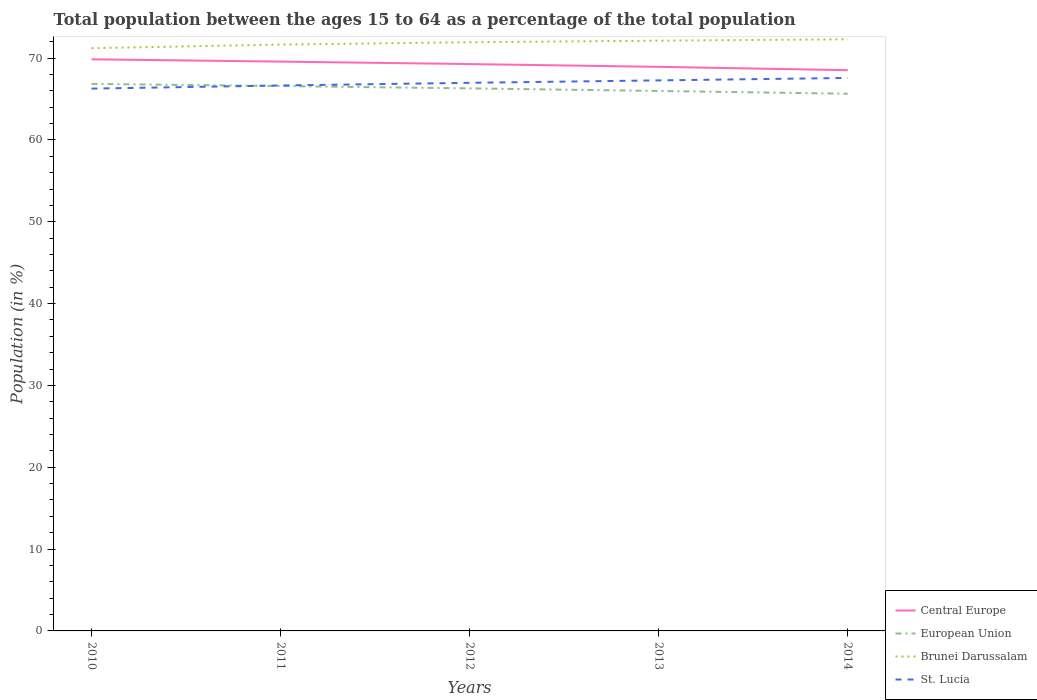Does the line corresponding to St. Lucia intersect with the line corresponding to Brunei Darussalam?
Offer a very short reply. No. Is the number of lines equal to the number of legend labels?
Provide a succinct answer. Yes. Across all years, what is the maximum percentage of the population ages 15 to 64 in Brunei Darussalam?
Make the answer very short. 71.21. In which year was the percentage of the population ages 15 to 64 in St. Lucia maximum?
Ensure brevity in your answer.  2010. What is the total percentage of the population ages 15 to 64 in European Union in the graph?
Keep it short and to the point. 1.2. What is the difference between the highest and the second highest percentage of the population ages 15 to 64 in St. Lucia?
Your answer should be very brief. 1.3. What is the difference between the highest and the lowest percentage of the population ages 15 to 64 in Brunei Darussalam?
Offer a very short reply. 3. How many years are there in the graph?
Provide a short and direct response. 5. Are the values on the major ticks of Y-axis written in scientific E-notation?
Make the answer very short. No. Does the graph contain grids?
Offer a very short reply. No. Where does the legend appear in the graph?
Provide a short and direct response. Bottom right. What is the title of the graph?
Provide a succinct answer. Total population between the ages 15 to 64 as a percentage of the total population. Does "Portugal" appear as one of the legend labels in the graph?
Ensure brevity in your answer.  No. What is the label or title of the Y-axis?
Your answer should be very brief. Population (in %). What is the Population (in %) in Central Europe in 2010?
Make the answer very short. 69.85. What is the Population (in %) of European Union in 2010?
Offer a terse response. 66.85. What is the Population (in %) of Brunei Darussalam in 2010?
Ensure brevity in your answer.  71.21. What is the Population (in %) in St. Lucia in 2010?
Offer a terse response. 66.27. What is the Population (in %) in Central Europe in 2011?
Ensure brevity in your answer.  69.57. What is the Population (in %) of European Union in 2011?
Provide a succinct answer. 66.58. What is the Population (in %) of Brunei Darussalam in 2011?
Offer a very short reply. 71.65. What is the Population (in %) of St. Lucia in 2011?
Offer a terse response. 66.65. What is the Population (in %) in Central Europe in 2012?
Your answer should be very brief. 69.27. What is the Population (in %) in European Union in 2012?
Provide a succinct answer. 66.3. What is the Population (in %) of Brunei Darussalam in 2012?
Offer a very short reply. 71.94. What is the Population (in %) of St. Lucia in 2012?
Provide a succinct answer. 66.98. What is the Population (in %) of Central Europe in 2013?
Ensure brevity in your answer.  68.93. What is the Population (in %) of European Union in 2013?
Offer a terse response. 65.99. What is the Population (in %) of Brunei Darussalam in 2013?
Make the answer very short. 72.13. What is the Population (in %) in St. Lucia in 2013?
Your response must be concise. 67.28. What is the Population (in %) of Central Europe in 2014?
Provide a short and direct response. 68.52. What is the Population (in %) of European Union in 2014?
Provide a short and direct response. 65.65. What is the Population (in %) of Brunei Darussalam in 2014?
Ensure brevity in your answer.  72.3. What is the Population (in %) in St. Lucia in 2014?
Provide a short and direct response. 67.58. Across all years, what is the maximum Population (in %) in Central Europe?
Keep it short and to the point. 69.85. Across all years, what is the maximum Population (in %) in European Union?
Make the answer very short. 66.85. Across all years, what is the maximum Population (in %) in Brunei Darussalam?
Your response must be concise. 72.3. Across all years, what is the maximum Population (in %) in St. Lucia?
Offer a very short reply. 67.58. Across all years, what is the minimum Population (in %) in Central Europe?
Your answer should be compact. 68.52. Across all years, what is the minimum Population (in %) of European Union?
Your response must be concise. 65.65. Across all years, what is the minimum Population (in %) of Brunei Darussalam?
Keep it short and to the point. 71.21. Across all years, what is the minimum Population (in %) in St. Lucia?
Give a very brief answer. 66.27. What is the total Population (in %) of Central Europe in the graph?
Give a very brief answer. 346.15. What is the total Population (in %) of European Union in the graph?
Keep it short and to the point. 331.36. What is the total Population (in %) in Brunei Darussalam in the graph?
Provide a succinct answer. 359.23. What is the total Population (in %) in St. Lucia in the graph?
Provide a succinct answer. 334.76. What is the difference between the Population (in %) of Central Europe in 2010 and that in 2011?
Your response must be concise. 0.28. What is the difference between the Population (in %) in European Union in 2010 and that in 2011?
Make the answer very short. 0.26. What is the difference between the Population (in %) of Brunei Darussalam in 2010 and that in 2011?
Make the answer very short. -0.44. What is the difference between the Population (in %) in St. Lucia in 2010 and that in 2011?
Offer a terse response. -0.38. What is the difference between the Population (in %) in Central Europe in 2010 and that in 2012?
Keep it short and to the point. 0.58. What is the difference between the Population (in %) of European Union in 2010 and that in 2012?
Provide a succinct answer. 0.55. What is the difference between the Population (in %) of Brunei Darussalam in 2010 and that in 2012?
Your answer should be compact. -0.73. What is the difference between the Population (in %) in St. Lucia in 2010 and that in 2012?
Keep it short and to the point. -0.71. What is the difference between the Population (in %) in Central Europe in 2010 and that in 2013?
Your answer should be very brief. 0.92. What is the difference between the Population (in %) in European Union in 2010 and that in 2013?
Make the answer very short. 0.86. What is the difference between the Population (in %) in Brunei Darussalam in 2010 and that in 2013?
Offer a very short reply. -0.92. What is the difference between the Population (in %) of St. Lucia in 2010 and that in 2013?
Your answer should be compact. -1. What is the difference between the Population (in %) in Central Europe in 2010 and that in 2014?
Your answer should be compact. 1.33. What is the difference between the Population (in %) of European Union in 2010 and that in 2014?
Keep it short and to the point. 1.2. What is the difference between the Population (in %) in Brunei Darussalam in 2010 and that in 2014?
Your answer should be compact. -1.09. What is the difference between the Population (in %) in St. Lucia in 2010 and that in 2014?
Offer a terse response. -1.3. What is the difference between the Population (in %) in Central Europe in 2011 and that in 2012?
Your answer should be compact. 0.3. What is the difference between the Population (in %) of European Union in 2011 and that in 2012?
Your answer should be compact. 0.28. What is the difference between the Population (in %) of Brunei Darussalam in 2011 and that in 2012?
Your response must be concise. -0.29. What is the difference between the Population (in %) in St. Lucia in 2011 and that in 2012?
Give a very brief answer. -0.32. What is the difference between the Population (in %) in Central Europe in 2011 and that in 2013?
Make the answer very short. 0.64. What is the difference between the Population (in %) in European Union in 2011 and that in 2013?
Provide a succinct answer. 0.6. What is the difference between the Population (in %) in Brunei Darussalam in 2011 and that in 2013?
Your answer should be very brief. -0.48. What is the difference between the Population (in %) of St. Lucia in 2011 and that in 2013?
Your response must be concise. -0.62. What is the difference between the Population (in %) in Central Europe in 2011 and that in 2014?
Provide a short and direct response. 1.05. What is the difference between the Population (in %) of European Union in 2011 and that in 2014?
Give a very brief answer. 0.94. What is the difference between the Population (in %) in Brunei Darussalam in 2011 and that in 2014?
Offer a terse response. -0.65. What is the difference between the Population (in %) of St. Lucia in 2011 and that in 2014?
Give a very brief answer. -0.92. What is the difference between the Population (in %) in Central Europe in 2012 and that in 2013?
Your response must be concise. 0.34. What is the difference between the Population (in %) in European Union in 2012 and that in 2013?
Make the answer very short. 0.31. What is the difference between the Population (in %) in Brunei Darussalam in 2012 and that in 2013?
Provide a succinct answer. -0.19. What is the difference between the Population (in %) in St. Lucia in 2012 and that in 2013?
Ensure brevity in your answer.  -0.3. What is the difference between the Population (in %) in Central Europe in 2012 and that in 2014?
Provide a short and direct response. 0.75. What is the difference between the Population (in %) of European Union in 2012 and that in 2014?
Provide a succinct answer. 0.65. What is the difference between the Population (in %) in Brunei Darussalam in 2012 and that in 2014?
Your response must be concise. -0.36. What is the difference between the Population (in %) of St. Lucia in 2012 and that in 2014?
Give a very brief answer. -0.6. What is the difference between the Population (in %) of Central Europe in 2013 and that in 2014?
Your answer should be compact. 0.41. What is the difference between the Population (in %) in European Union in 2013 and that in 2014?
Offer a very short reply. 0.34. What is the difference between the Population (in %) in Brunei Darussalam in 2013 and that in 2014?
Your answer should be compact. -0.17. What is the difference between the Population (in %) in St. Lucia in 2013 and that in 2014?
Your answer should be compact. -0.3. What is the difference between the Population (in %) of Central Europe in 2010 and the Population (in %) of European Union in 2011?
Your answer should be very brief. 3.27. What is the difference between the Population (in %) of Central Europe in 2010 and the Population (in %) of Brunei Darussalam in 2011?
Make the answer very short. -1.8. What is the difference between the Population (in %) in Central Europe in 2010 and the Population (in %) in St. Lucia in 2011?
Offer a terse response. 3.2. What is the difference between the Population (in %) of European Union in 2010 and the Population (in %) of Brunei Darussalam in 2011?
Offer a very short reply. -4.8. What is the difference between the Population (in %) in European Union in 2010 and the Population (in %) in St. Lucia in 2011?
Offer a terse response. 0.19. What is the difference between the Population (in %) in Brunei Darussalam in 2010 and the Population (in %) in St. Lucia in 2011?
Offer a very short reply. 4.56. What is the difference between the Population (in %) of Central Europe in 2010 and the Population (in %) of European Union in 2012?
Give a very brief answer. 3.55. What is the difference between the Population (in %) of Central Europe in 2010 and the Population (in %) of Brunei Darussalam in 2012?
Offer a very short reply. -2.09. What is the difference between the Population (in %) in Central Europe in 2010 and the Population (in %) in St. Lucia in 2012?
Offer a very short reply. 2.87. What is the difference between the Population (in %) in European Union in 2010 and the Population (in %) in Brunei Darussalam in 2012?
Offer a very short reply. -5.09. What is the difference between the Population (in %) in European Union in 2010 and the Population (in %) in St. Lucia in 2012?
Give a very brief answer. -0.13. What is the difference between the Population (in %) of Brunei Darussalam in 2010 and the Population (in %) of St. Lucia in 2012?
Ensure brevity in your answer.  4.23. What is the difference between the Population (in %) in Central Europe in 2010 and the Population (in %) in European Union in 2013?
Offer a terse response. 3.87. What is the difference between the Population (in %) of Central Europe in 2010 and the Population (in %) of Brunei Darussalam in 2013?
Provide a succinct answer. -2.28. What is the difference between the Population (in %) of Central Europe in 2010 and the Population (in %) of St. Lucia in 2013?
Keep it short and to the point. 2.58. What is the difference between the Population (in %) of European Union in 2010 and the Population (in %) of Brunei Darussalam in 2013?
Give a very brief answer. -5.28. What is the difference between the Population (in %) in European Union in 2010 and the Population (in %) in St. Lucia in 2013?
Offer a terse response. -0.43. What is the difference between the Population (in %) in Brunei Darussalam in 2010 and the Population (in %) in St. Lucia in 2013?
Provide a succinct answer. 3.93. What is the difference between the Population (in %) of Central Europe in 2010 and the Population (in %) of European Union in 2014?
Your response must be concise. 4.2. What is the difference between the Population (in %) in Central Europe in 2010 and the Population (in %) in Brunei Darussalam in 2014?
Your answer should be very brief. -2.45. What is the difference between the Population (in %) of Central Europe in 2010 and the Population (in %) of St. Lucia in 2014?
Your answer should be very brief. 2.28. What is the difference between the Population (in %) of European Union in 2010 and the Population (in %) of Brunei Darussalam in 2014?
Provide a succinct answer. -5.45. What is the difference between the Population (in %) of European Union in 2010 and the Population (in %) of St. Lucia in 2014?
Make the answer very short. -0.73. What is the difference between the Population (in %) of Brunei Darussalam in 2010 and the Population (in %) of St. Lucia in 2014?
Ensure brevity in your answer.  3.63. What is the difference between the Population (in %) in Central Europe in 2011 and the Population (in %) in European Union in 2012?
Your answer should be compact. 3.27. What is the difference between the Population (in %) of Central Europe in 2011 and the Population (in %) of Brunei Darussalam in 2012?
Your answer should be compact. -2.37. What is the difference between the Population (in %) in Central Europe in 2011 and the Population (in %) in St. Lucia in 2012?
Offer a very short reply. 2.59. What is the difference between the Population (in %) of European Union in 2011 and the Population (in %) of Brunei Darussalam in 2012?
Your response must be concise. -5.36. What is the difference between the Population (in %) in European Union in 2011 and the Population (in %) in St. Lucia in 2012?
Offer a very short reply. -0.39. What is the difference between the Population (in %) of Brunei Darussalam in 2011 and the Population (in %) of St. Lucia in 2012?
Offer a terse response. 4.67. What is the difference between the Population (in %) in Central Europe in 2011 and the Population (in %) in European Union in 2013?
Ensure brevity in your answer.  3.59. What is the difference between the Population (in %) of Central Europe in 2011 and the Population (in %) of Brunei Darussalam in 2013?
Provide a succinct answer. -2.56. What is the difference between the Population (in %) of Central Europe in 2011 and the Population (in %) of St. Lucia in 2013?
Your answer should be very brief. 2.3. What is the difference between the Population (in %) in European Union in 2011 and the Population (in %) in Brunei Darussalam in 2013?
Offer a terse response. -5.55. What is the difference between the Population (in %) in European Union in 2011 and the Population (in %) in St. Lucia in 2013?
Provide a short and direct response. -0.69. What is the difference between the Population (in %) in Brunei Darussalam in 2011 and the Population (in %) in St. Lucia in 2013?
Offer a terse response. 4.38. What is the difference between the Population (in %) of Central Europe in 2011 and the Population (in %) of European Union in 2014?
Your answer should be compact. 3.92. What is the difference between the Population (in %) in Central Europe in 2011 and the Population (in %) in Brunei Darussalam in 2014?
Provide a succinct answer. -2.73. What is the difference between the Population (in %) of Central Europe in 2011 and the Population (in %) of St. Lucia in 2014?
Make the answer very short. 2. What is the difference between the Population (in %) of European Union in 2011 and the Population (in %) of Brunei Darussalam in 2014?
Your answer should be very brief. -5.71. What is the difference between the Population (in %) of European Union in 2011 and the Population (in %) of St. Lucia in 2014?
Keep it short and to the point. -0.99. What is the difference between the Population (in %) of Brunei Darussalam in 2011 and the Population (in %) of St. Lucia in 2014?
Ensure brevity in your answer.  4.08. What is the difference between the Population (in %) in Central Europe in 2012 and the Population (in %) in European Union in 2013?
Provide a succinct answer. 3.29. What is the difference between the Population (in %) in Central Europe in 2012 and the Population (in %) in Brunei Darussalam in 2013?
Provide a short and direct response. -2.86. What is the difference between the Population (in %) in Central Europe in 2012 and the Population (in %) in St. Lucia in 2013?
Offer a very short reply. 1.99. What is the difference between the Population (in %) of European Union in 2012 and the Population (in %) of Brunei Darussalam in 2013?
Give a very brief answer. -5.83. What is the difference between the Population (in %) of European Union in 2012 and the Population (in %) of St. Lucia in 2013?
Ensure brevity in your answer.  -0.98. What is the difference between the Population (in %) in Brunei Darussalam in 2012 and the Population (in %) in St. Lucia in 2013?
Keep it short and to the point. 4.66. What is the difference between the Population (in %) of Central Europe in 2012 and the Population (in %) of European Union in 2014?
Your answer should be compact. 3.62. What is the difference between the Population (in %) in Central Europe in 2012 and the Population (in %) in Brunei Darussalam in 2014?
Keep it short and to the point. -3.03. What is the difference between the Population (in %) in Central Europe in 2012 and the Population (in %) in St. Lucia in 2014?
Offer a very short reply. 1.69. What is the difference between the Population (in %) in European Union in 2012 and the Population (in %) in Brunei Darussalam in 2014?
Provide a short and direct response. -6. What is the difference between the Population (in %) of European Union in 2012 and the Population (in %) of St. Lucia in 2014?
Your response must be concise. -1.28. What is the difference between the Population (in %) of Brunei Darussalam in 2012 and the Population (in %) of St. Lucia in 2014?
Offer a terse response. 4.36. What is the difference between the Population (in %) in Central Europe in 2013 and the Population (in %) in European Union in 2014?
Your answer should be compact. 3.28. What is the difference between the Population (in %) of Central Europe in 2013 and the Population (in %) of Brunei Darussalam in 2014?
Offer a terse response. -3.37. What is the difference between the Population (in %) of Central Europe in 2013 and the Population (in %) of St. Lucia in 2014?
Offer a terse response. 1.36. What is the difference between the Population (in %) of European Union in 2013 and the Population (in %) of Brunei Darussalam in 2014?
Ensure brevity in your answer.  -6.31. What is the difference between the Population (in %) in European Union in 2013 and the Population (in %) in St. Lucia in 2014?
Your answer should be compact. -1.59. What is the difference between the Population (in %) in Brunei Darussalam in 2013 and the Population (in %) in St. Lucia in 2014?
Make the answer very short. 4.55. What is the average Population (in %) in Central Europe per year?
Your response must be concise. 69.23. What is the average Population (in %) of European Union per year?
Offer a terse response. 66.27. What is the average Population (in %) in Brunei Darussalam per year?
Your answer should be very brief. 71.85. What is the average Population (in %) of St. Lucia per year?
Provide a succinct answer. 66.95. In the year 2010, what is the difference between the Population (in %) of Central Europe and Population (in %) of European Union?
Offer a very short reply. 3. In the year 2010, what is the difference between the Population (in %) of Central Europe and Population (in %) of Brunei Darussalam?
Your response must be concise. -1.36. In the year 2010, what is the difference between the Population (in %) in Central Europe and Population (in %) in St. Lucia?
Offer a very short reply. 3.58. In the year 2010, what is the difference between the Population (in %) in European Union and Population (in %) in Brunei Darussalam?
Offer a terse response. -4.36. In the year 2010, what is the difference between the Population (in %) in European Union and Population (in %) in St. Lucia?
Keep it short and to the point. 0.58. In the year 2010, what is the difference between the Population (in %) in Brunei Darussalam and Population (in %) in St. Lucia?
Offer a very short reply. 4.94. In the year 2011, what is the difference between the Population (in %) in Central Europe and Population (in %) in European Union?
Offer a very short reply. 2.99. In the year 2011, what is the difference between the Population (in %) in Central Europe and Population (in %) in Brunei Darussalam?
Your response must be concise. -2.08. In the year 2011, what is the difference between the Population (in %) of Central Europe and Population (in %) of St. Lucia?
Your answer should be compact. 2.92. In the year 2011, what is the difference between the Population (in %) in European Union and Population (in %) in Brunei Darussalam?
Make the answer very short. -5.07. In the year 2011, what is the difference between the Population (in %) in European Union and Population (in %) in St. Lucia?
Make the answer very short. -0.07. In the year 2011, what is the difference between the Population (in %) of Brunei Darussalam and Population (in %) of St. Lucia?
Ensure brevity in your answer.  5. In the year 2012, what is the difference between the Population (in %) in Central Europe and Population (in %) in European Union?
Make the answer very short. 2.97. In the year 2012, what is the difference between the Population (in %) of Central Europe and Population (in %) of Brunei Darussalam?
Keep it short and to the point. -2.67. In the year 2012, what is the difference between the Population (in %) of Central Europe and Population (in %) of St. Lucia?
Keep it short and to the point. 2.29. In the year 2012, what is the difference between the Population (in %) of European Union and Population (in %) of Brunei Darussalam?
Your answer should be very brief. -5.64. In the year 2012, what is the difference between the Population (in %) of European Union and Population (in %) of St. Lucia?
Offer a very short reply. -0.68. In the year 2012, what is the difference between the Population (in %) in Brunei Darussalam and Population (in %) in St. Lucia?
Keep it short and to the point. 4.96. In the year 2013, what is the difference between the Population (in %) of Central Europe and Population (in %) of European Union?
Provide a short and direct response. 2.95. In the year 2013, what is the difference between the Population (in %) in Central Europe and Population (in %) in Brunei Darussalam?
Your answer should be compact. -3.2. In the year 2013, what is the difference between the Population (in %) in Central Europe and Population (in %) in St. Lucia?
Your answer should be very brief. 1.66. In the year 2013, what is the difference between the Population (in %) in European Union and Population (in %) in Brunei Darussalam?
Provide a succinct answer. -6.14. In the year 2013, what is the difference between the Population (in %) of European Union and Population (in %) of St. Lucia?
Ensure brevity in your answer.  -1.29. In the year 2013, what is the difference between the Population (in %) in Brunei Darussalam and Population (in %) in St. Lucia?
Your response must be concise. 4.85. In the year 2014, what is the difference between the Population (in %) of Central Europe and Population (in %) of European Union?
Keep it short and to the point. 2.88. In the year 2014, what is the difference between the Population (in %) in Central Europe and Population (in %) in Brunei Darussalam?
Offer a very short reply. -3.77. In the year 2014, what is the difference between the Population (in %) of Central Europe and Population (in %) of St. Lucia?
Offer a very short reply. 0.95. In the year 2014, what is the difference between the Population (in %) in European Union and Population (in %) in Brunei Darussalam?
Provide a succinct answer. -6.65. In the year 2014, what is the difference between the Population (in %) of European Union and Population (in %) of St. Lucia?
Offer a very short reply. -1.93. In the year 2014, what is the difference between the Population (in %) in Brunei Darussalam and Population (in %) in St. Lucia?
Give a very brief answer. 4.72. What is the ratio of the Population (in %) in Central Europe in 2010 to that in 2011?
Offer a very short reply. 1. What is the ratio of the Population (in %) of European Union in 2010 to that in 2011?
Your answer should be compact. 1. What is the ratio of the Population (in %) in Brunei Darussalam in 2010 to that in 2011?
Your answer should be compact. 0.99. What is the ratio of the Population (in %) of Central Europe in 2010 to that in 2012?
Make the answer very short. 1.01. What is the ratio of the Population (in %) in European Union in 2010 to that in 2012?
Keep it short and to the point. 1.01. What is the ratio of the Population (in %) of Central Europe in 2010 to that in 2013?
Make the answer very short. 1.01. What is the ratio of the Population (in %) in European Union in 2010 to that in 2013?
Offer a terse response. 1.01. What is the ratio of the Population (in %) of Brunei Darussalam in 2010 to that in 2013?
Your answer should be very brief. 0.99. What is the ratio of the Population (in %) in St. Lucia in 2010 to that in 2013?
Make the answer very short. 0.99. What is the ratio of the Population (in %) in Central Europe in 2010 to that in 2014?
Make the answer very short. 1.02. What is the ratio of the Population (in %) of European Union in 2010 to that in 2014?
Your answer should be compact. 1.02. What is the ratio of the Population (in %) in St. Lucia in 2010 to that in 2014?
Provide a short and direct response. 0.98. What is the ratio of the Population (in %) in European Union in 2011 to that in 2012?
Provide a succinct answer. 1. What is the ratio of the Population (in %) in Central Europe in 2011 to that in 2013?
Make the answer very short. 1.01. What is the ratio of the Population (in %) in European Union in 2011 to that in 2013?
Make the answer very short. 1.01. What is the ratio of the Population (in %) in Brunei Darussalam in 2011 to that in 2013?
Offer a terse response. 0.99. What is the ratio of the Population (in %) of St. Lucia in 2011 to that in 2013?
Offer a very short reply. 0.99. What is the ratio of the Population (in %) in Central Europe in 2011 to that in 2014?
Offer a terse response. 1.02. What is the ratio of the Population (in %) of European Union in 2011 to that in 2014?
Ensure brevity in your answer.  1.01. What is the ratio of the Population (in %) of Brunei Darussalam in 2011 to that in 2014?
Make the answer very short. 0.99. What is the ratio of the Population (in %) of St. Lucia in 2011 to that in 2014?
Offer a very short reply. 0.99. What is the ratio of the Population (in %) in Central Europe in 2012 to that in 2013?
Provide a short and direct response. 1. What is the ratio of the Population (in %) in St. Lucia in 2012 to that in 2013?
Your response must be concise. 1. What is the ratio of the Population (in %) in Central Europe in 2012 to that in 2014?
Offer a terse response. 1.01. What is the ratio of the Population (in %) of St. Lucia in 2012 to that in 2014?
Give a very brief answer. 0.99. What is the ratio of the Population (in %) of Central Europe in 2013 to that in 2014?
Offer a very short reply. 1.01. What is the ratio of the Population (in %) in European Union in 2013 to that in 2014?
Your answer should be compact. 1.01. What is the ratio of the Population (in %) in Brunei Darussalam in 2013 to that in 2014?
Offer a very short reply. 1. What is the ratio of the Population (in %) in St. Lucia in 2013 to that in 2014?
Offer a terse response. 1. What is the difference between the highest and the second highest Population (in %) of Central Europe?
Your answer should be compact. 0.28. What is the difference between the highest and the second highest Population (in %) in European Union?
Your response must be concise. 0.26. What is the difference between the highest and the second highest Population (in %) of Brunei Darussalam?
Ensure brevity in your answer.  0.17. What is the difference between the highest and the second highest Population (in %) in St. Lucia?
Provide a succinct answer. 0.3. What is the difference between the highest and the lowest Population (in %) in Central Europe?
Your response must be concise. 1.33. What is the difference between the highest and the lowest Population (in %) of European Union?
Your answer should be very brief. 1.2. What is the difference between the highest and the lowest Population (in %) of Brunei Darussalam?
Your answer should be compact. 1.09. What is the difference between the highest and the lowest Population (in %) in St. Lucia?
Give a very brief answer. 1.3. 